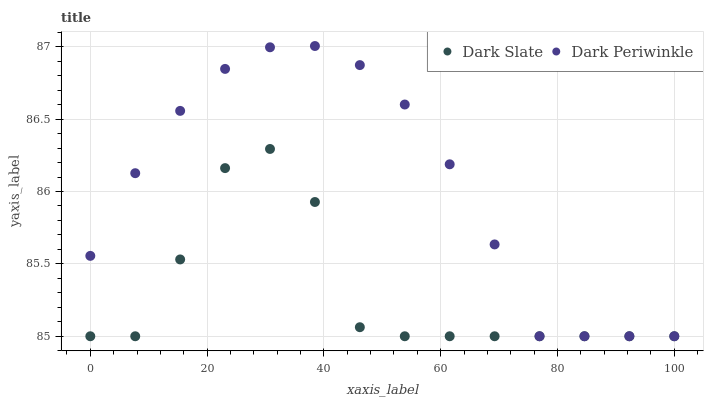Does Dark Slate have the minimum area under the curve?
Answer yes or no. Yes. Does Dark Periwinkle have the maximum area under the curve?
Answer yes or no. Yes. Does Dark Periwinkle have the minimum area under the curve?
Answer yes or no. No. Is Dark Periwinkle the smoothest?
Answer yes or no. Yes. Is Dark Slate the roughest?
Answer yes or no. Yes. Is Dark Periwinkle the roughest?
Answer yes or no. No. Does Dark Slate have the lowest value?
Answer yes or no. Yes. Does Dark Periwinkle have the highest value?
Answer yes or no. Yes. Does Dark Slate intersect Dark Periwinkle?
Answer yes or no. Yes. Is Dark Slate less than Dark Periwinkle?
Answer yes or no. No. Is Dark Slate greater than Dark Periwinkle?
Answer yes or no. No. 